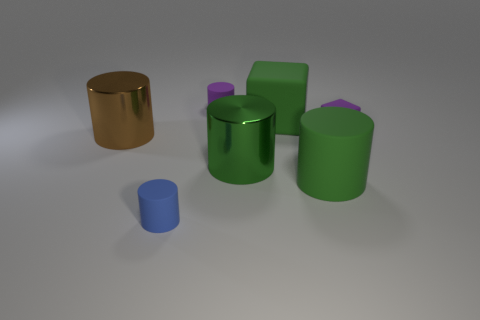There is a cylinder to the left of the small blue rubber thing; what number of purple matte cylinders are in front of it?
Give a very brief answer. 0. There is another cylinder that is the same color as the large matte cylinder; what is it made of?
Your response must be concise. Metal. What number of other objects are the same color as the large block?
Offer a terse response. 2. There is a matte block on the right side of the large object that is behind the big brown shiny object; what color is it?
Provide a short and direct response. Purple. Is there a big metal cylinder that has the same color as the big matte cube?
Your response must be concise. Yes. How many rubber objects are large cyan spheres or large brown cylinders?
Your answer should be compact. 0. Are there any small purple cylinders made of the same material as the blue cylinder?
Provide a succinct answer. Yes. What number of cylinders are both on the left side of the big block and in front of the large green rubber block?
Offer a very short reply. 3. Is the number of tiny purple things that are in front of the blue object less than the number of purple things on the right side of the purple rubber cylinder?
Ensure brevity in your answer.  Yes. Do the brown metallic object and the green metallic thing have the same shape?
Ensure brevity in your answer.  Yes. 